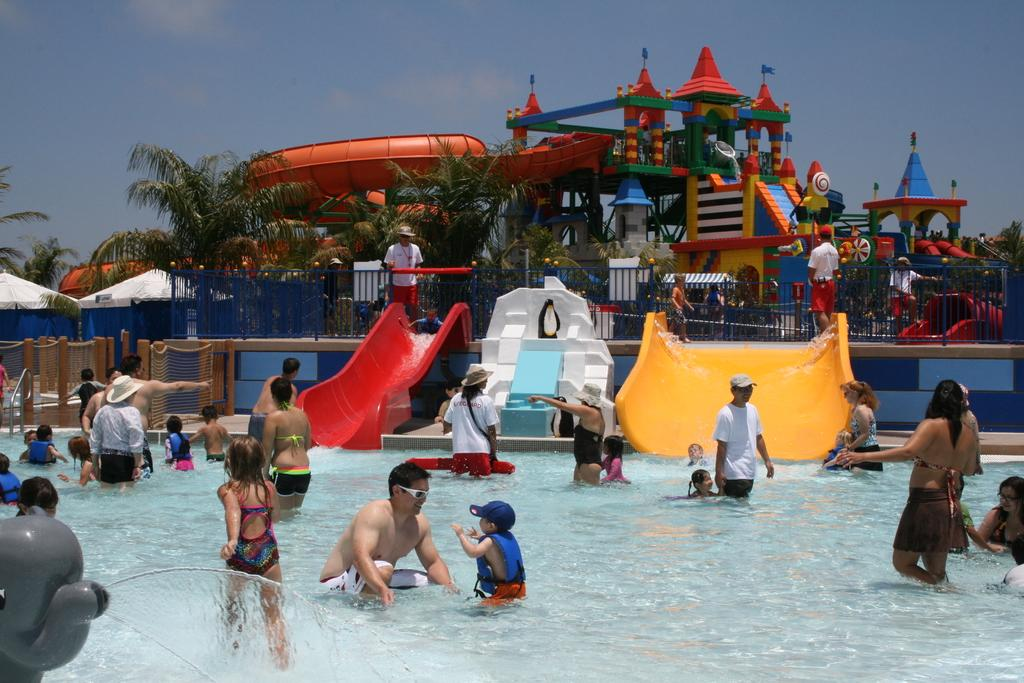What is the main feature in the image? There is a pool in the image. What are the people in the image doing? People are enjoying in the pool. What other attractions can be seen in the image? There are different types of water rides visible in the image. What can be seen in the background of the image? Trees are present in the background of the image. What is used to secure the pool area? There is a fencing around the pool. What type of rice is being served in the image? There is no rice present in the image; it features a pool with people enjoying and water rides. 